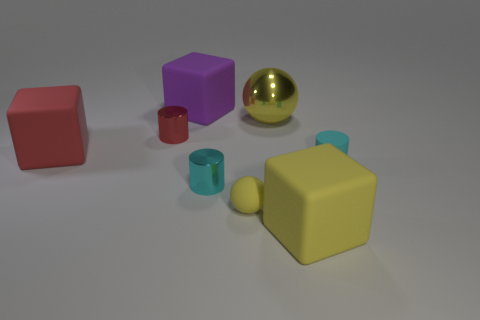Add 1 yellow metallic balls. How many objects exist? 9 Subtract all spheres. How many objects are left? 6 Subtract all small blue shiny things. Subtract all purple blocks. How many objects are left? 7 Add 4 large purple blocks. How many large purple blocks are left? 5 Add 8 large purple shiny cylinders. How many large purple shiny cylinders exist? 8 Subtract 0 blue blocks. How many objects are left? 8 